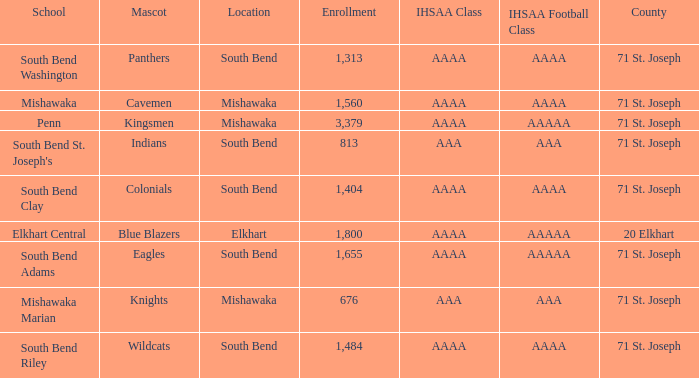What school has south bend as the location, with indians as the mascot? South Bend St. Joseph's. 